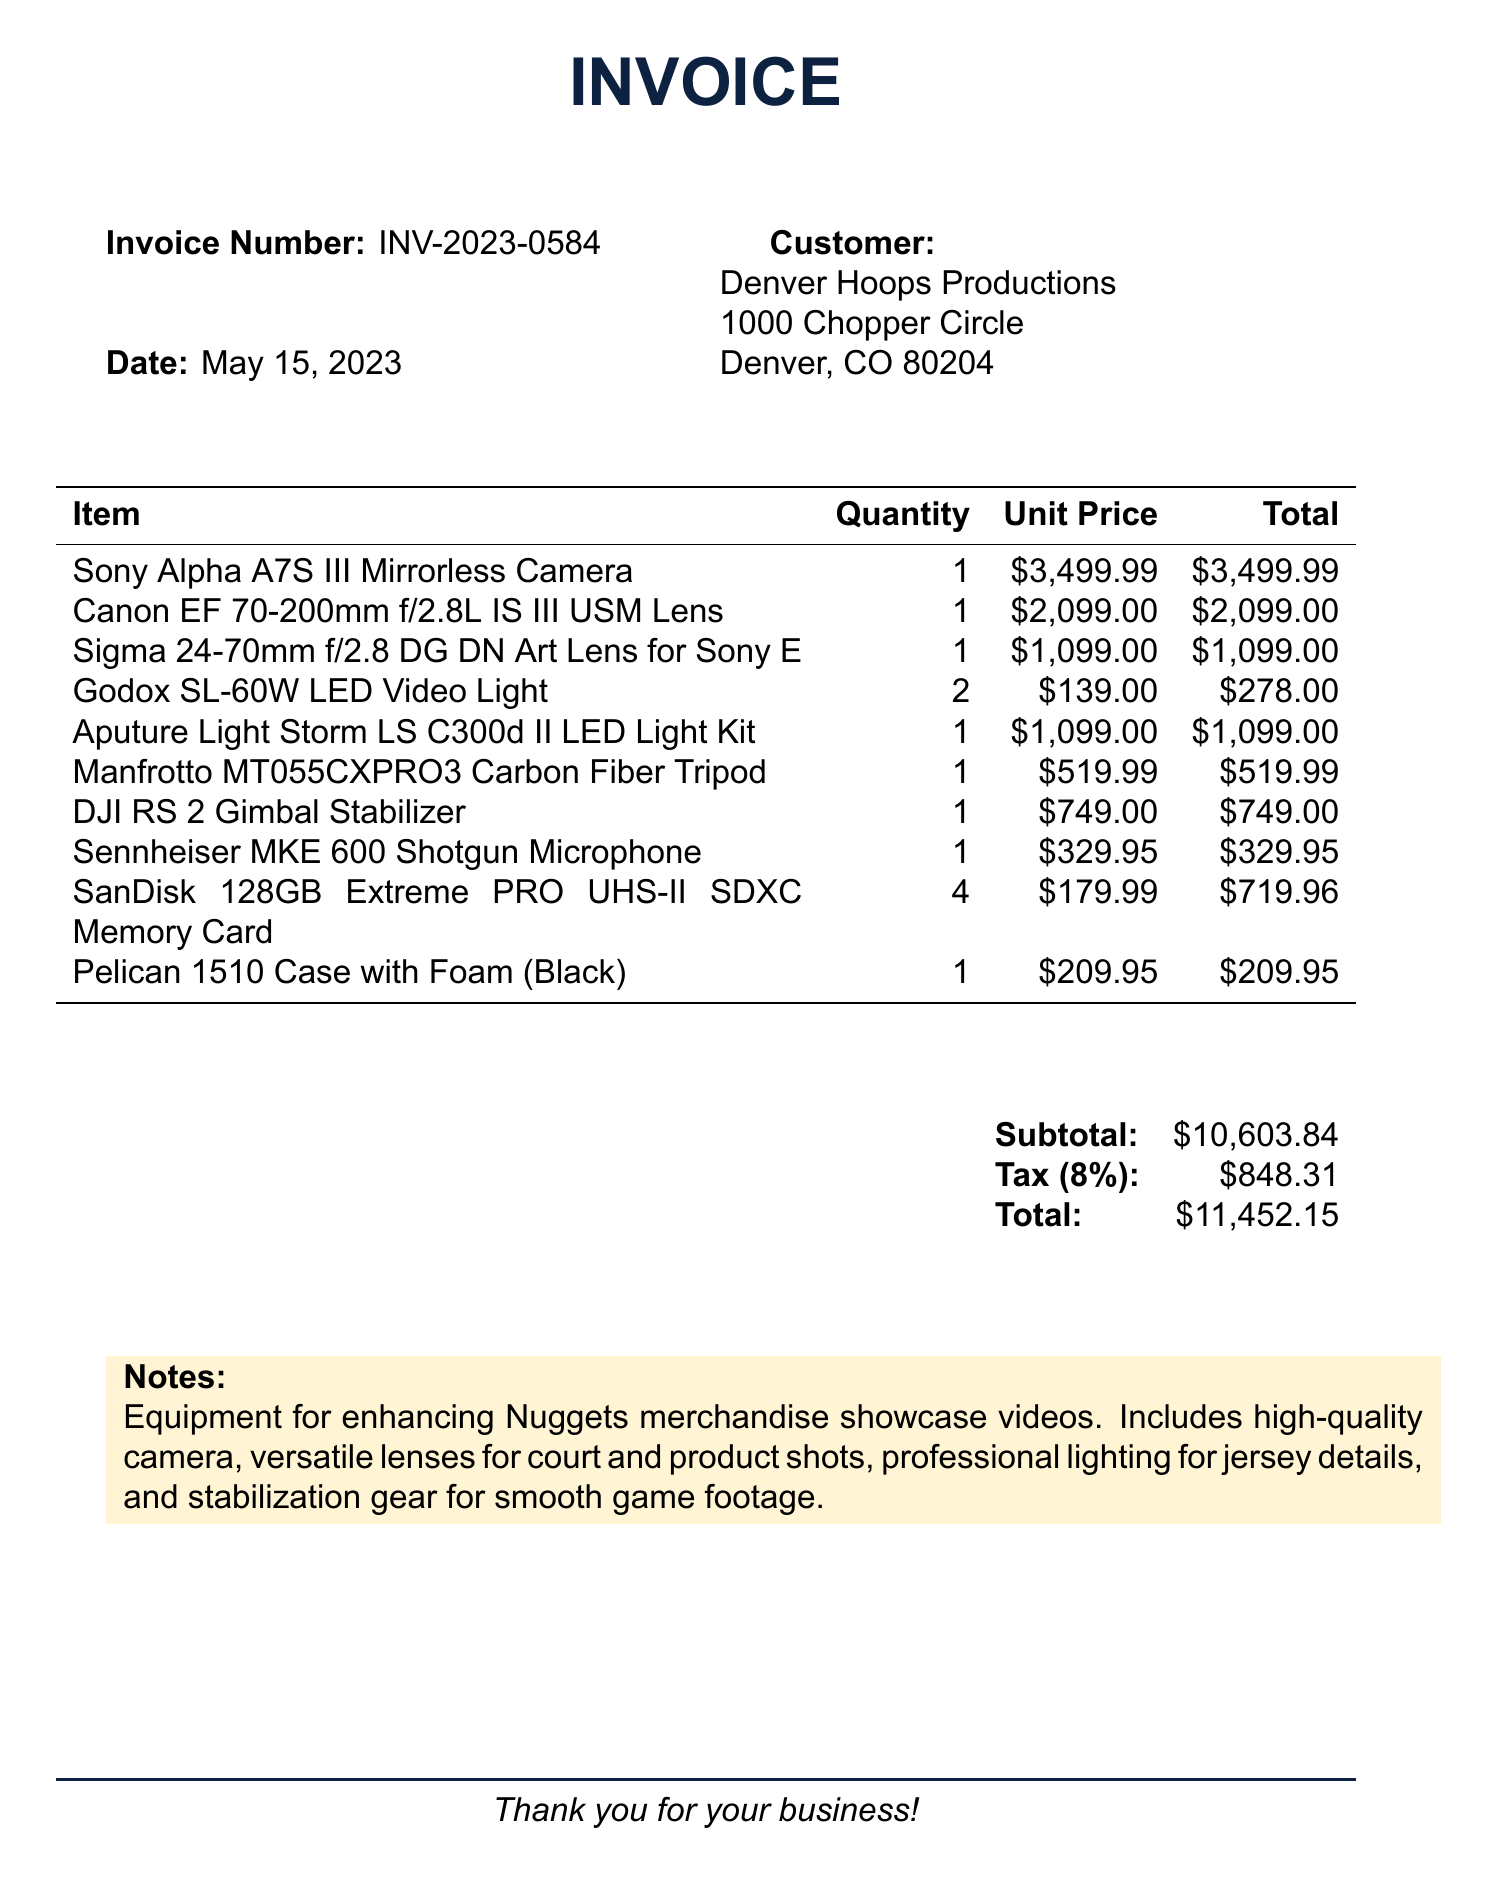What is the invoice number? The invoice number is a unique identifier for the transaction, specified at the top of the document.
Answer: INV-2023-0584 Who is the customer? The customer name is listed near the top of the document, detailing who the invoice is for.
Answer: Denver Hoops Productions What is the total amount due? The total amount due is the sum of the subtotal and tax, found at the bottom of the invoice.
Answer: $11,452.15 How many SanDisk 128GB Extreme PRO UHS-II SDXC Memory Cards were purchased? The quantity of SanDisk memory cards is listed in the itemized section of the invoice.
Answer: 4 What was the unit price of the Aputure Light Storm LS C300d II LED Light Kit? The unit price is indicated in the itemized list, showing the cost for one of this item.
Answer: $1,099.00 What is the tax rate applied to this invoice? The tax rate is expressed as a percentage and can be found in the summary section of the invoice.
Answer: 8% What does the note mention about the equipment? The note provides additional context about the purpose of the purchased equipment.
Answer: Enhancing Nuggets merchandise showcase videos How many Godox SL-60W LED Video Lights were purchased? The quantity of Godox LED lights is detailed in the itemized list showing how many units were bought.
Answer: 2 What is the subtotal before tax is added? The subtotal is the sum of all item totals excluding tax, found in the summary section of the invoice.
Answer: $10,603.84 What type of document is this? The format and content indicate the nature of the document as a record of a financial transaction.
Answer: Invoice 